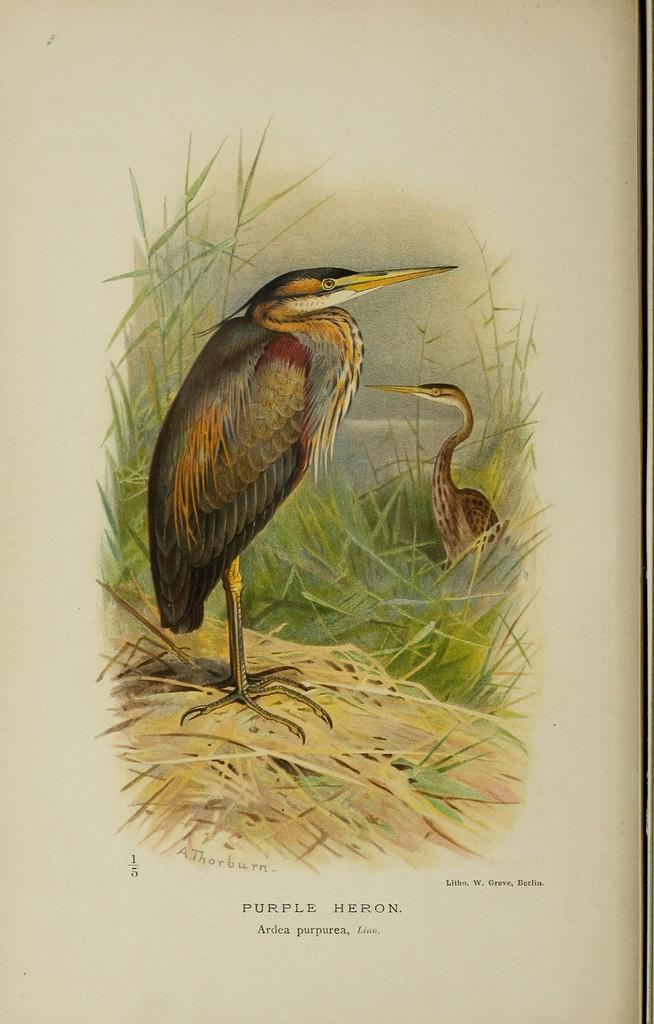What is the main subject in the center of the image? There is a paper in the center of the image. What can be seen on the paper? There is a drawing on the paper. Is there any text on the paper? Yes, there is text at the bottom of the paper. How many frogs are jumping around the drawing on the paper? There are no frogs present in the image, as the drawing on the paper is not described in the facts. 